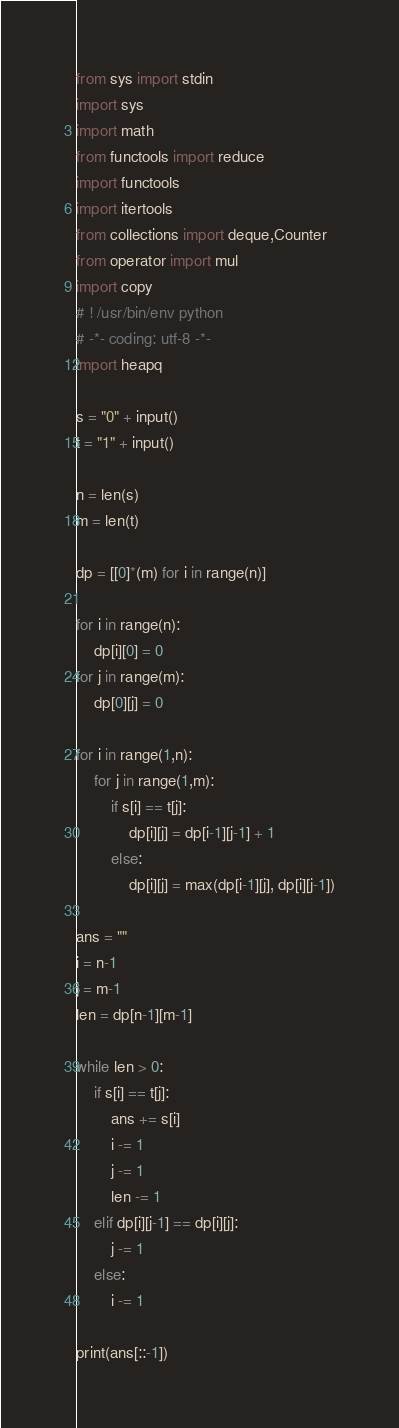Convert code to text. <code><loc_0><loc_0><loc_500><loc_500><_Python_>from sys import stdin
import sys
import math
from functools import reduce
import functools
import itertools
from collections import deque,Counter
from operator import mul
import copy
# ! /usr/bin/env python
# -*- coding: utf-8 -*-
import heapq

s = "0" + input()
t = "1" + input()

n = len(s)
m = len(t)

dp = [[0]*(m) for i in range(n)]

for i in range(n):
    dp[i][0] = 0
for j in range(m):
    dp[0][j] = 0

for i in range(1,n):
    for j in range(1,m):
        if s[i] == t[j]:
            dp[i][j] = dp[i-1][j-1] + 1
        else:
            dp[i][j] = max(dp[i-1][j], dp[i][j-1])

ans = ""
i = n-1
j = m-1
len = dp[n-1][m-1]

while len > 0:
    if s[i] == t[j]:
        ans += s[i]
        i -= 1
        j -= 1
        len -= 1
    elif dp[i][j-1] == dp[i][j]:
        j -= 1
    else:
        i -= 1

print(ans[::-1])
</code> 